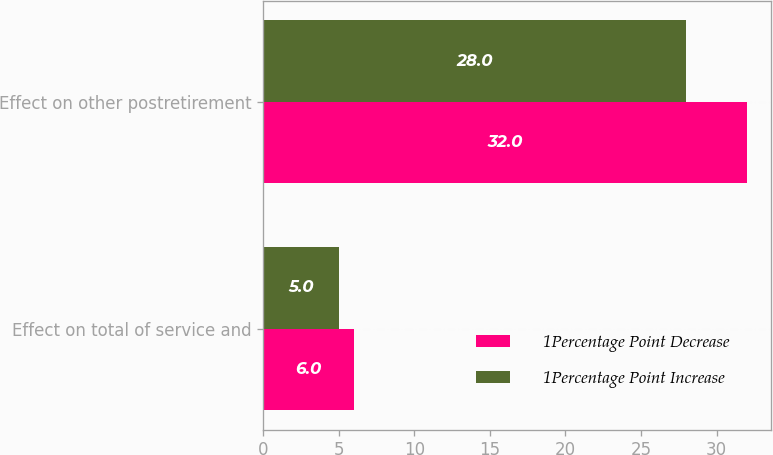Convert chart. <chart><loc_0><loc_0><loc_500><loc_500><stacked_bar_chart><ecel><fcel>Effect on total of service and<fcel>Effect on other postretirement<nl><fcel>1Percentage Point Decrease<fcel>6<fcel>32<nl><fcel>1Percentage Point Increase<fcel>5<fcel>28<nl></chart> 